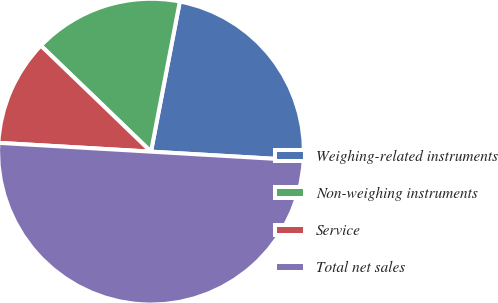<chart> <loc_0><loc_0><loc_500><loc_500><pie_chart><fcel>Weighing-related instruments<fcel>Non-weighing instruments<fcel>Service<fcel>Total net sales<nl><fcel>22.9%<fcel>15.82%<fcel>11.28%<fcel>50.0%<nl></chart> 